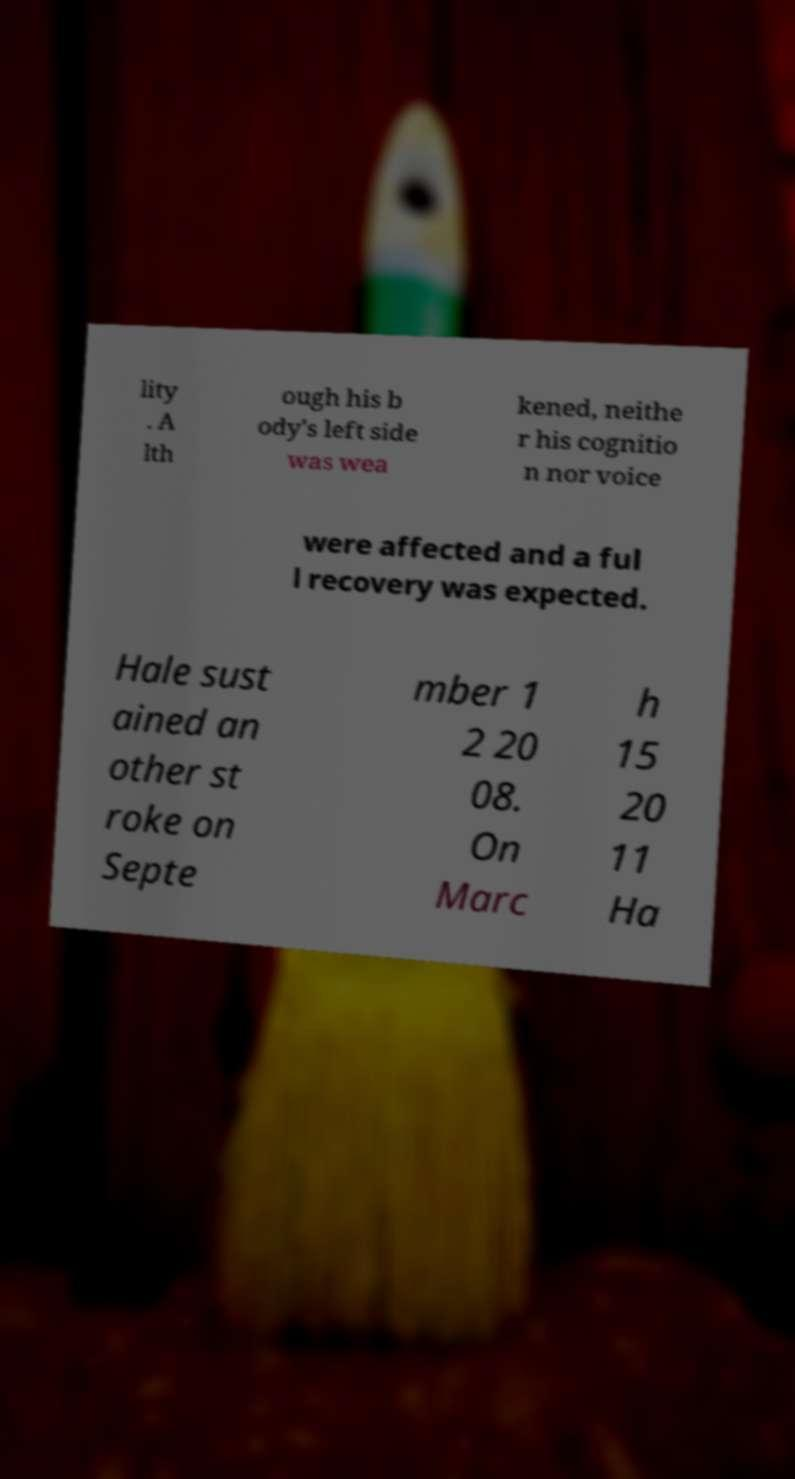Please read and relay the text visible in this image. What does it say? lity . A lth ough his b ody's left side was wea kened, neithe r his cognitio n nor voice were affected and a ful l recovery was expected. Hale sust ained an other st roke on Septe mber 1 2 20 08. On Marc h 15 20 11 Ha 